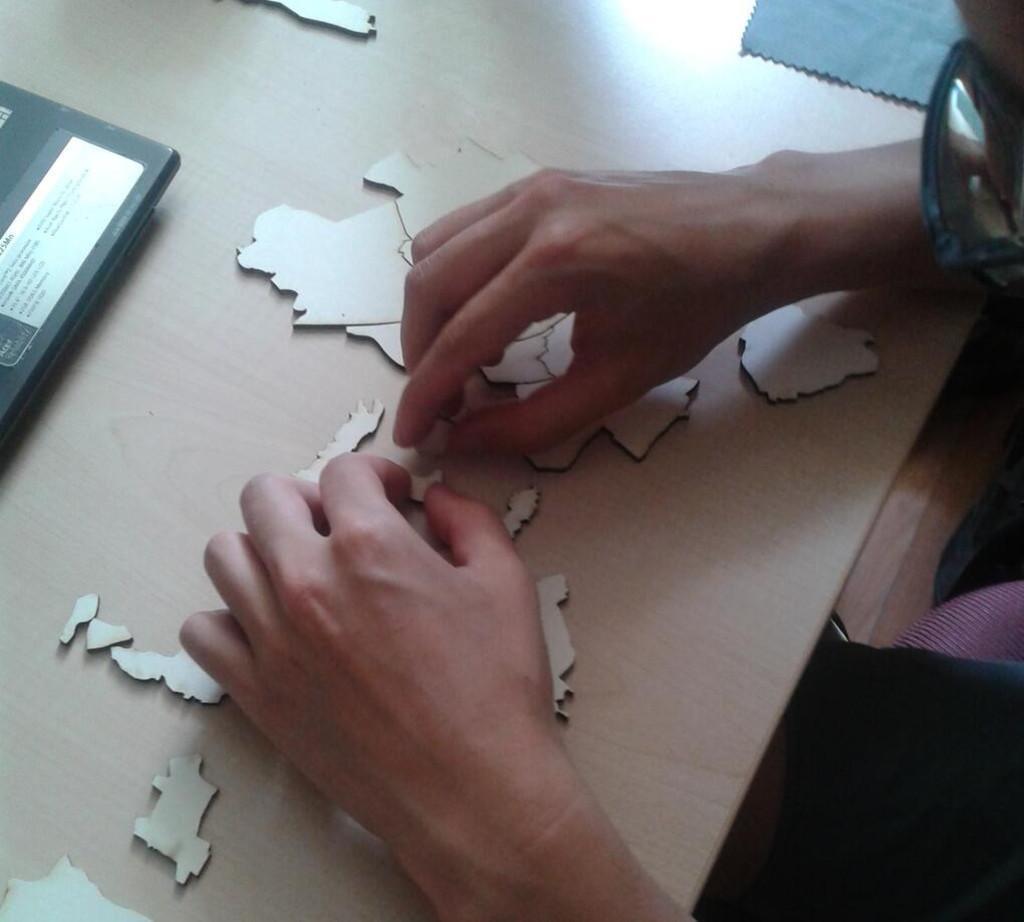Could you give a brief overview of what you see in this image? In this picture we can see hands of a person solving puzzle. Here we can see a cloth and an object on a wooden platform. 